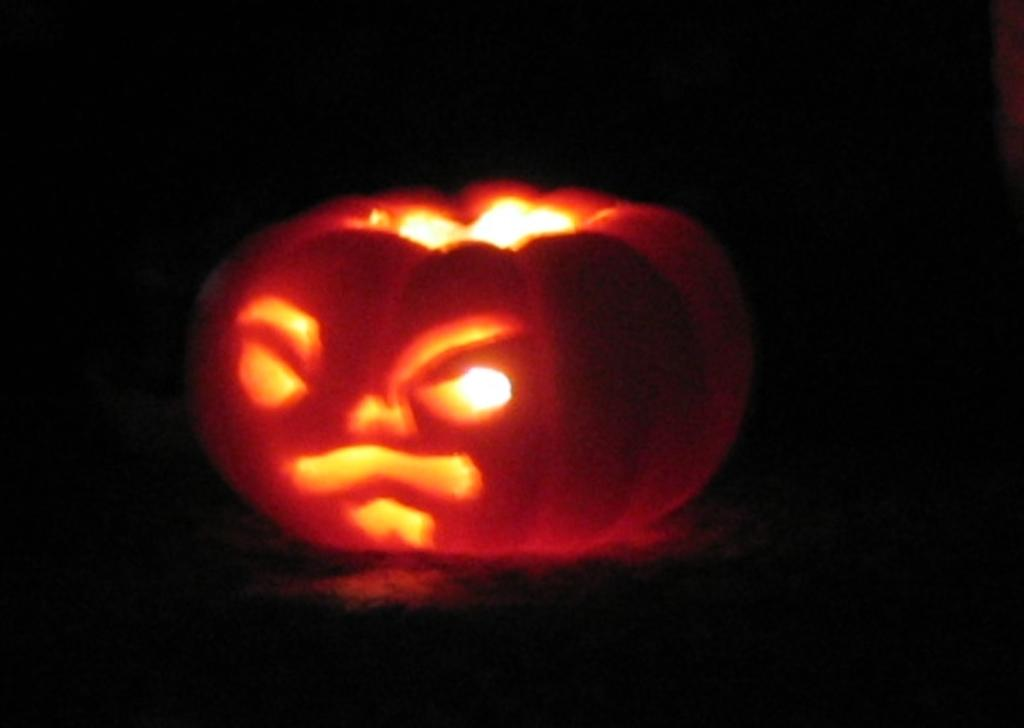What is the color of the background in the image? The background of the image is dark. What can be seen in the middle of the image? There is an unknown object in the middle of the image. How many times does the sheet fall in the image? There is no sheet present in the image, so it cannot be determined how many times it falls. 